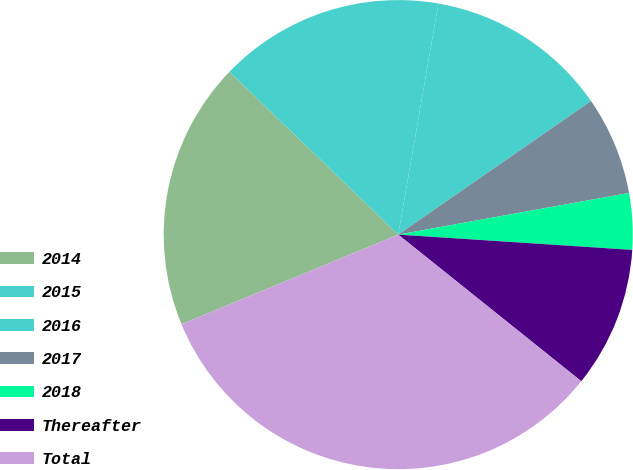Convert chart to OTSL. <chart><loc_0><loc_0><loc_500><loc_500><pie_chart><fcel>2014<fcel>2015<fcel>2016<fcel>2017<fcel>2018<fcel>Thereafter<fcel>Total<nl><fcel>18.45%<fcel>15.53%<fcel>12.62%<fcel>6.8%<fcel>3.88%<fcel>9.71%<fcel>33.01%<nl></chart> 